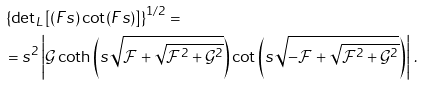Convert formula to latex. <formula><loc_0><loc_0><loc_500><loc_500>& \left \{ { \det } _ { L } \left [ ( F s ) \cot ( F s ) \right ] \right \} ^ { 1 / 2 } = \\ & = s ^ { 2 } \left | \mathcal { G } \coth \left ( s \sqrt { \mathcal { F } + \sqrt { \mathcal { F } ^ { 2 } + \mathcal { G } ^ { 2 } } } \right ) \cot \left ( s \sqrt { - \mathcal { F } + \sqrt { \mathcal { F } ^ { 2 } + \mathcal { G } ^ { 2 } } } \right ) \right | \, .</formula> 